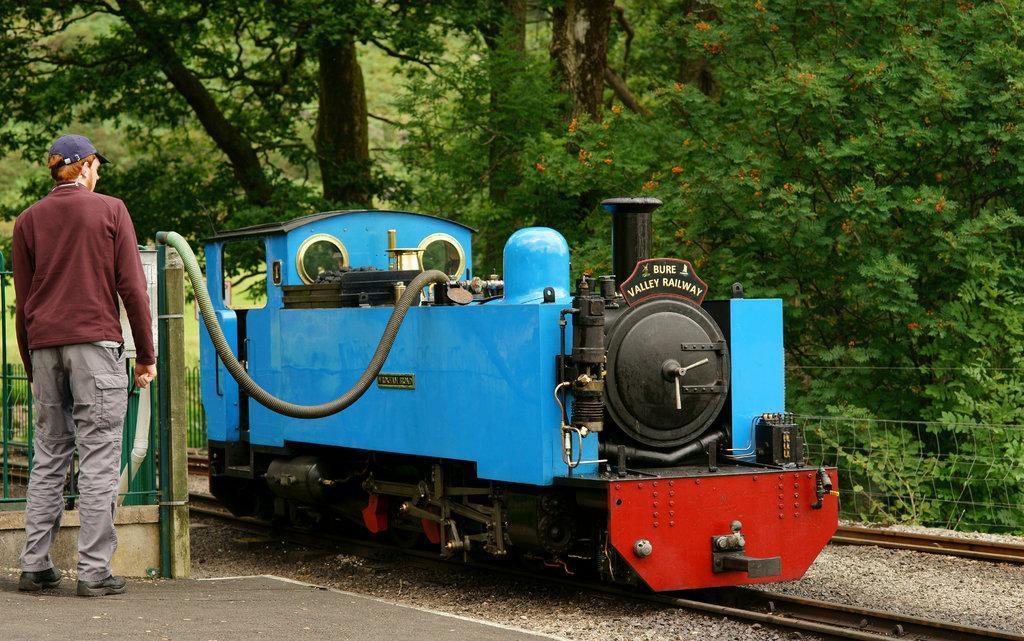In one or two sentences, can you explain what this image depicts? In this image there is a train engine on the railway track , there is a person standing , and in the background there are trees. 